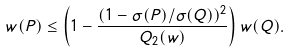Convert formula to latex. <formula><loc_0><loc_0><loc_500><loc_500>w ( P ) \leq \left ( 1 - \frac { ( 1 - \sigma ( P ) / \sigma ( Q ) ) ^ { 2 } } { Q _ { 2 } ( w ) } \right ) w ( Q ) .</formula> 